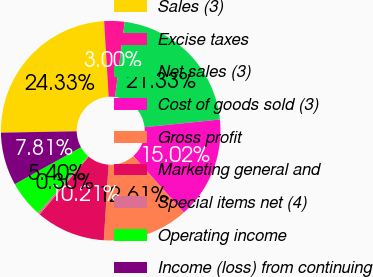Convert chart. <chart><loc_0><loc_0><loc_500><loc_500><pie_chart><fcel>Sales (3)<fcel>Excise taxes<fcel>Net sales (3)<fcel>Cost of goods sold (3)<fcel>Gross profit<fcel>Marketing general and<fcel>Special items net (4)<fcel>Operating income<fcel>Income (loss) from continuing<nl><fcel>24.33%<fcel>3.0%<fcel>21.33%<fcel>15.02%<fcel>12.61%<fcel>10.21%<fcel>0.3%<fcel>5.4%<fcel>7.81%<nl></chart> 